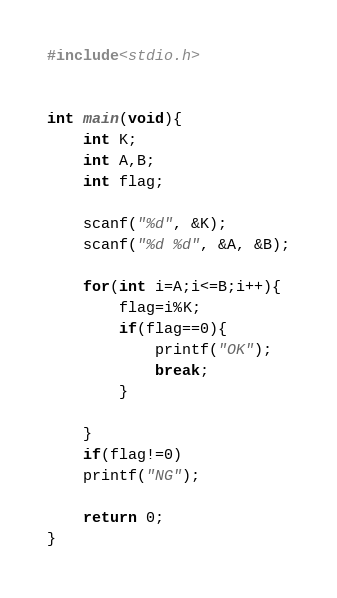<code> <loc_0><loc_0><loc_500><loc_500><_C_>#include<stdio.h>


int main(void){
    int K;
    int A,B;
    int flag;

    scanf("%d", &K);
    scanf("%d %d", &A, &B);

    for(int i=A;i<=B;i++){
        flag=i%K;
        if(flag==0){
            printf("OK");
            break;
        }

    }
    if(flag!=0)
    printf("NG");

    return 0;
}</code> 